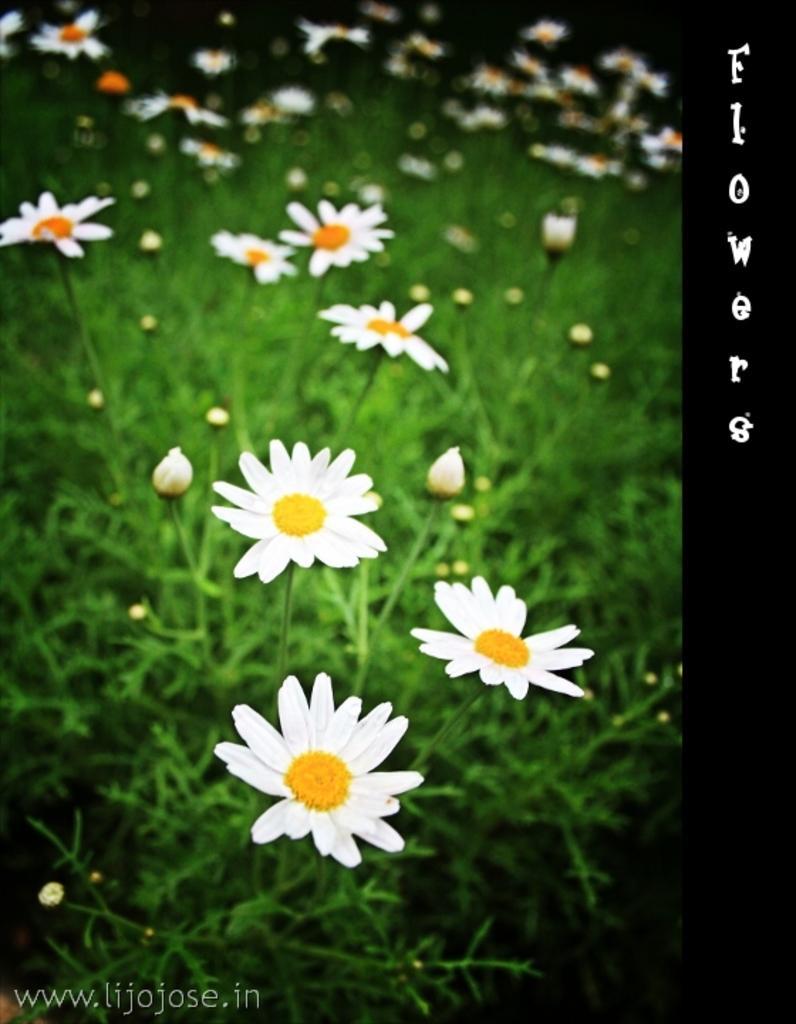Can you describe this image briefly? This is an edited picture. I can see flowers, buds and there is a watermark on the image. 